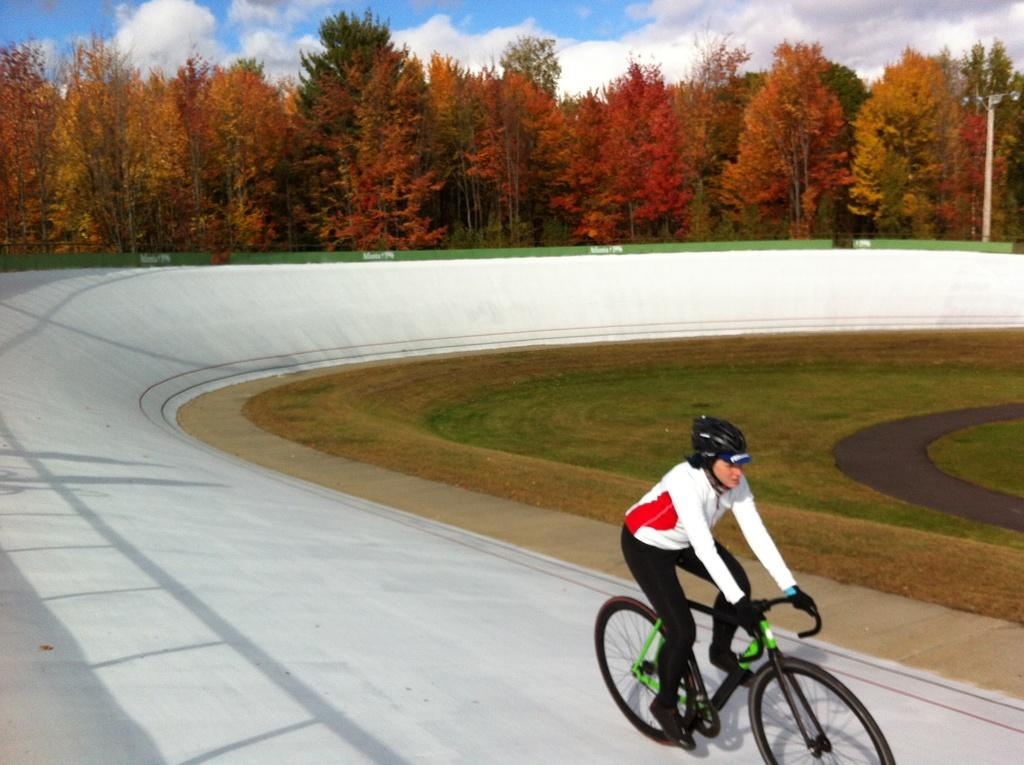What is the main subject of the image? There is a person in the image. What is the person wearing? The person is wearing clothes, shoes, a helmet, and gloves. What activity is the person engaged in? The person is riding a bicycle. What type of terrain can be seen in the image? There is grass in the image. What structures are present in the background? There is a light pole in the image. What can be seen in the sky? The sky is cloudy. What type of bean is being used as a caption for the image? There is no bean or caption present in the image. Can you tell me how many lakes are visible in the image? There are no lakes visible in the image. 